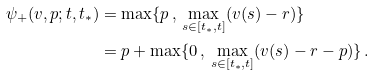Convert formula to latex. <formula><loc_0><loc_0><loc_500><loc_500>\psi _ { + } ( v , p ; t , t _ { * } ) & = \max \{ p \, , \, \max _ { s \in [ t _ { * } , t ] } ( v ( s ) - r ) \} \\ & = p + \max \{ 0 \, , \, \max _ { s \in [ t _ { * } , t ] } ( v ( s ) - r - p ) \} \, .</formula> 